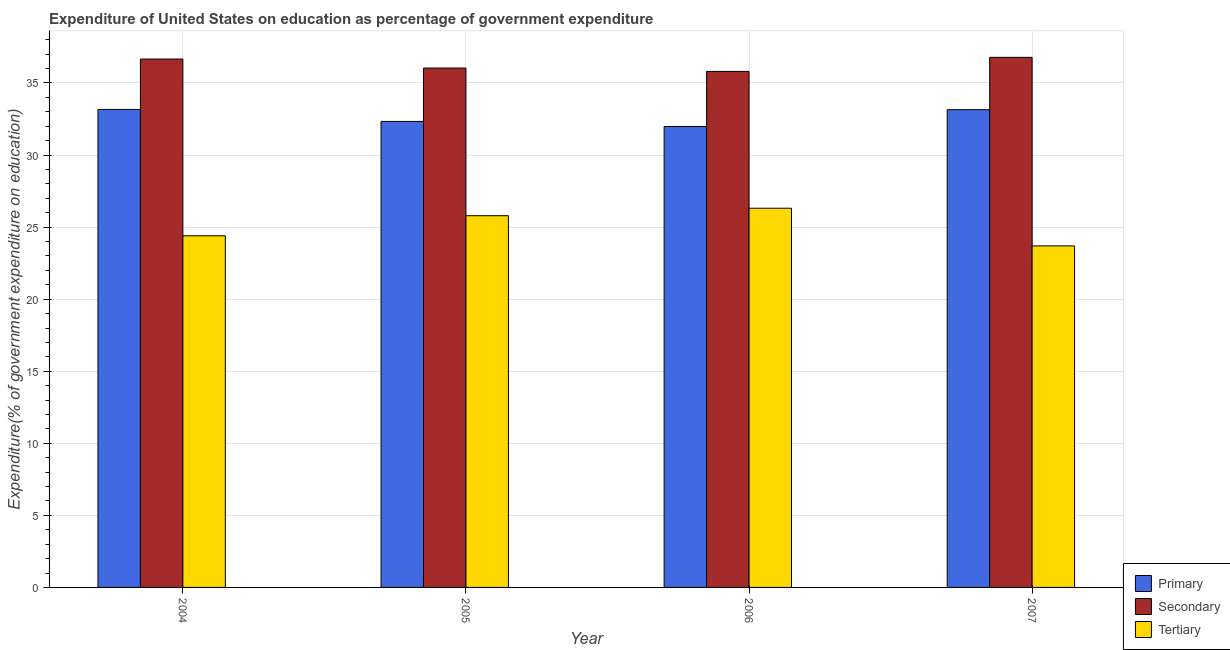Are the number of bars per tick equal to the number of legend labels?
Keep it short and to the point. Yes. In how many cases, is the number of bars for a given year not equal to the number of legend labels?
Keep it short and to the point. 0. What is the expenditure on tertiary education in 2006?
Provide a succinct answer. 26.31. Across all years, what is the maximum expenditure on primary education?
Your answer should be very brief. 33.16. Across all years, what is the minimum expenditure on primary education?
Provide a short and direct response. 31.98. What is the total expenditure on primary education in the graph?
Keep it short and to the point. 130.63. What is the difference between the expenditure on tertiary education in 2004 and that in 2006?
Give a very brief answer. -1.91. What is the difference between the expenditure on primary education in 2007 and the expenditure on secondary education in 2005?
Your answer should be compact. 0.81. What is the average expenditure on tertiary education per year?
Give a very brief answer. 25.05. In the year 2006, what is the difference between the expenditure on primary education and expenditure on secondary education?
Your answer should be compact. 0. What is the ratio of the expenditure on primary education in 2005 to that in 2006?
Offer a terse response. 1.01. Is the expenditure on secondary education in 2005 less than that in 2007?
Your answer should be very brief. Yes. What is the difference between the highest and the second highest expenditure on tertiary education?
Ensure brevity in your answer.  0.52. What is the difference between the highest and the lowest expenditure on secondary education?
Make the answer very short. 0.97. What does the 2nd bar from the left in 2005 represents?
Offer a terse response. Secondary. What does the 3rd bar from the right in 2007 represents?
Provide a succinct answer. Primary. Is it the case that in every year, the sum of the expenditure on primary education and expenditure on secondary education is greater than the expenditure on tertiary education?
Ensure brevity in your answer.  Yes. How many bars are there?
Provide a succinct answer. 12. Are all the bars in the graph horizontal?
Keep it short and to the point. No. How many years are there in the graph?
Keep it short and to the point. 4. Does the graph contain any zero values?
Your response must be concise. No. Does the graph contain grids?
Keep it short and to the point. Yes. How are the legend labels stacked?
Provide a short and direct response. Vertical. What is the title of the graph?
Make the answer very short. Expenditure of United States on education as percentage of government expenditure. Does "Neonatal" appear as one of the legend labels in the graph?
Give a very brief answer. No. What is the label or title of the X-axis?
Make the answer very short. Year. What is the label or title of the Y-axis?
Provide a short and direct response. Expenditure(% of government expenditure on education). What is the Expenditure(% of government expenditure on education) of Primary in 2004?
Your response must be concise. 33.16. What is the Expenditure(% of government expenditure on education) in Secondary in 2004?
Your answer should be very brief. 36.66. What is the Expenditure(% of government expenditure on education) of Tertiary in 2004?
Your answer should be very brief. 24.4. What is the Expenditure(% of government expenditure on education) of Primary in 2005?
Your answer should be compact. 32.33. What is the Expenditure(% of government expenditure on education) in Secondary in 2005?
Offer a very short reply. 36.04. What is the Expenditure(% of government expenditure on education) in Tertiary in 2005?
Give a very brief answer. 25.79. What is the Expenditure(% of government expenditure on education) of Primary in 2006?
Offer a very short reply. 31.98. What is the Expenditure(% of government expenditure on education) in Secondary in 2006?
Provide a succinct answer. 35.81. What is the Expenditure(% of government expenditure on education) in Tertiary in 2006?
Your answer should be very brief. 26.31. What is the Expenditure(% of government expenditure on education) of Primary in 2007?
Offer a very short reply. 33.15. What is the Expenditure(% of government expenditure on education) of Secondary in 2007?
Provide a succinct answer. 36.78. What is the Expenditure(% of government expenditure on education) of Tertiary in 2007?
Your response must be concise. 23.7. Across all years, what is the maximum Expenditure(% of government expenditure on education) in Primary?
Keep it short and to the point. 33.16. Across all years, what is the maximum Expenditure(% of government expenditure on education) of Secondary?
Your answer should be very brief. 36.78. Across all years, what is the maximum Expenditure(% of government expenditure on education) in Tertiary?
Your response must be concise. 26.31. Across all years, what is the minimum Expenditure(% of government expenditure on education) of Primary?
Provide a short and direct response. 31.98. Across all years, what is the minimum Expenditure(% of government expenditure on education) in Secondary?
Keep it short and to the point. 35.81. Across all years, what is the minimum Expenditure(% of government expenditure on education) of Tertiary?
Your response must be concise. 23.7. What is the total Expenditure(% of government expenditure on education) of Primary in the graph?
Offer a very short reply. 130.63. What is the total Expenditure(% of government expenditure on education) of Secondary in the graph?
Offer a terse response. 145.29. What is the total Expenditure(% of government expenditure on education) in Tertiary in the graph?
Provide a short and direct response. 100.2. What is the difference between the Expenditure(% of government expenditure on education) of Primary in 2004 and that in 2005?
Provide a short and direct response. 0.83. What is the difference between the Expenditure(% of government expenditure on education) of Secondary in 2004 and that in 2005?
Provide a short and direct response. 0.62. What is the difference between the Expenditure(% of government expenditure on education) of Tertiary in 2004 and that in 2005?
Offer a terse response. -1.39. What is the difference between the Expenditure(% of government expenditure on education) in Primary in 2004 and that in 2006?
Your response must be concise. 1.18. What is the difference between the Expenditure(% of government expenditure on education) of Secondary in 2004 and that in 2006?
Make the answer very short. 0.86. What is the difference between the Expenditure(% of government expenditure on education) of Tertiary in 2004 and that in 2006?
Provide a short and direct response. -1.91. What is the difference between the Expenditure(% of government expenditure on education) of Primary in 2004 and that in 2007?
Make the answer very short. 0.02. What is the difference between the Expenditure(% of government expenditure on education) in Secondary in 2004 and that in 2007?
Provide a short and direct response. -0.12. What is the difference between the Expenditure(% of government expenditure on education) of Tertiary in 2004 and that in 2007?
Provide a short and direct response. 0.7. What is the difference between the Expenditure(% of government expenditure on education) of Primary in 2005 and that in 2006?
Your response must be concise. 0.35. What is the difference between the Expenditure(% of government expenditure on education) of Secondary in 2005 and that in 2006?
Provide a succinct answer. 0.23. What is the difference between the Expenditure(% of government expenditure on education) in Tertiary in 2005 and that in 2006?
Give a very brief answer. -0.52. What is the difference between the Expenditure(% of government expenditure on education) in Primary in 2005 and that in 2007?
Your answer should be very brief. -0.81. What is the difference between the Expenditure(% of government expenditure on education) in Secondary in 2005 and that in 2007?
Provide a short and direct response. -0.74. What is the difference between the Expenditure(% of government expenditure on education) in Tertiary in 2005 and that in 2007?
Provide a succinct answer. 2.09. What is the difference between the Expenditure(% of government expenditure on education) of Primary in 2006 and that in 2007?
Your response must be concise. -1.16. What is the difference between the Expenditure(% of government expenditure on education) in Secondary in 2006 and that in 2007?
Offer a terse response. -0.97. What is the difference between the Expenditure(% of government expenditure on education) in Tertiary in 2006 and that in 2007?
Offer a very short reply. 2.61. What is the difference between the Expenditure(% of government expenditure on education) of Primary in 2004 and the Expenditure(% of government expenditure on education) of Secondary in 2005?
Offer a terse response. -2.87. What is the difference between the Expenditure(% of government expenditure on education) in Primary in 2004 and the Expenditure(% of government expenditure on education) in Tertiary in 2005?
Give a very brief answer. 7.37. What is the difference between the Expenditure(% of government expenditure on education) of Secondary in 2004 and the Expenditure(% of government expenditure on education) of Tertiary in 2005?
Keep it short and to the point. 10.87. What is the difference between the Expenditure(% of government expenditure on education) in Primary in 2004 and the Expenditure(% of government expenditure on education) in Secondary in 2006?
Provide a short and direct response. -2.64. What is the difference between the Expenditure(% of government expenditure on education) of Primary in 2004 and the Expenditure(% of government expenditure on education) of Tertiary in 2006?
Your answer should be compact. 6.85. What is the difference between the Expenditure(% of government expenditure on education) in Secondary in 2004 and the Expenditure(% of government expenditure on education) in Tertiary in 2006?
Offer a very short reply. 10.35. What is the difference between the Expenditure(% of government expenditure on education) of Primary in 2004 and the Expenditure(% of government expenditure on education) of Secondary in 2007?
Your answer should be compact. -3.62. What is the difference between the Expenditure(% of government expenditure on education) of Primary in 2004 and the Expenditure(% of government expenditure on education) of Tertiary in 2007?
Make the answer very short. 9.47. What is the difference between the Expenditure(% of government expenditure on education) in Secondary in 2004 and the Expenditure(% of government expenditure on education) in Tertiary in 2007?
Your response must be concise. 12.96. What is the difference between the Expenditure(% of government expenditure on education) in Primary in 2005 and the Expenditure(% of government expenditure on education) in Secondary in 2006?
Make the answer very short. -3.47. What is the difference between the Expenditure(% of government expenditure on education) in Primary in 2005 and the Expenditure(% of government expenditure on education) in Tertiary in 2006?
Provide a succinct answer. 6.02. What is the difference between the Expenditure(% of government expenditure on education) of Secondary in 2005 and the Expenditure(% of government expenditure on education) of Tertiary in 2006?
Give a very brief answer. 9.73. What is the difference between the Expenditure(% of government expenditure on education) of Primary in 2005 and the Expenditure(% of government expenditure on education) of Secondary in 2007?
Offer a very short reply. -4.45. What is the difference between the Expenditure(% of government expenditure on education) in Primary in 2005 and the Expenditure(% of government expenditure on education) in Tertiary in 2007?
Make the answer very short. 8.64. What is the difference between the Expenditure(% of government expenditure on education) in Secondary in 2005 and the Expenditure(% of government expenditure on education) in Tertiary in 2007?
Ensure brevity in your answer.  12.34. What is the difference between the Expenditure(% of government expenditure on education) in Primary in 2006 and the Expenditure(% of government expenditure on education) in Secondary in 2007?
Your answer should be very brief. -4.8. What is the difference between the Expenditure(% of government expenditure on education) in Primary in 2006 and the Expenditure(% of government expenditure on education) in Tertiary in 2007?
Your answer should be compact. 8.29. What is the difference between the Expenditure(% of government expenditure on education) in Secondary in 2006 and the Expenditure(% of government expenditure on education) in Tertiary in 2007?
Provide a short and direct response. 12.11. What is the average Expenditure(% of government expenditure on education) of Primary per year?
Keep it short and to the point. 32.66. What is the average Expenditure(% of government expenditure on education) of Secondary per year?
Give a very brief answer. 36.32. What is the average Expenditure(% of government expenditure on education) of Tertiary per year?
Keep it short and to the point. 25.05. In the year 2004, what is the difference between the Expenditure(% of government expenditure on education) of Primary and Expenditure(% of government expenditure on education) of Secondary?
Provide a succinct answer. -3.5. In the year 2004, what is the difference between the Expenditure(% of government expenditure on education) in Primary and Expenditure(% of government expenditure on education) in Tertiary?
Make the answer very short. 8.77. In the year 2004, what is the difference between the Expenditure(% of government expenditure on education) in Secondary and Expenditure(% of government expenditure on education) in Tertiary?
Your response must be concise. 12.26. In the year 2005, what is the difference between the Expenditure(% of government expenditure on education) of Primary and Expenditure(% of government expenditure on education) of Secondary?
Offer a very short reply. -3.7. In the year 2005, what is the difference between the Expenditure(% of government expenditure on education) in Primary and Expenditure(% of government expenditure on education) in Tertiary?
Give a very brief answer. 6.54. In the year 2005, what is the difference between the Expenditure(% of government expenditure on education) of Secondary and Expenditure(% of government expenditure on education) of Tertiary?
Provide a succinct answer. 10.25. In the year 2006, what is the difference between the Expenditure(% of government expenditure on education) in Primary and Expenditure(% of government expenditure on education) in Secondary?
Your response must be concise. -3.82. In the year 2006, what is the difference between the Expenditure(% of government expenditure on education) in Primary and Expenditure(% of government expenditure on education) in Tertiary?
Keep it short and to the point. 5.67. In the year 2006, what is the difference between the Expenditure(% of government expenditure on education) of Secondary and Expenditure(% of government expenditure on education) of Tertiary?
Ensure brevity in your answer.  9.5. In the year 2007, what is the difference between the Expenditure(% of government expenditure on education) of Primary and Expenditure(% of government expenditure on education) of Secondary?
Ensure brevity in your answer.  -3.63. In the year 2007, what is the difference between the Expenditure(% of government expenditure on education) of Primary and Expenditure(% of government expenditure on education) of Tertiary?
Provide a succinct answer. 9.45. In the year 2007, what is the difference between the Expenditure(% of government expenditure on education) in Secondary and Expenditure(% of government expenditure on education) in Tertiary?
Offer a terse response. 13.08. What is the ratio of the Expenditure(% of government expenditure on education) in Primary in 2004 to that in 2005?
Give a very brief answer. 1.03. What is the ratio of the Expenditure(% of government expenditure on education) in Secondary in 2004 to that in 2005?
Keep it short and to the point. 1.02. What is the ratio of the Expenditure(% of government expenditure on education) of Tertiary in 2004 to that in 2005?
Offer a terse response. 0.95. What is the ratio of the Expenditure(% of government expenditure on education) of Primary in 2004 to that in 2006?
Offer a terse response. 1.04. What is the ratio of the Expenditure(% of government expenditure on education) of Secondary in 2004 to that in 2006?
Give a very brief answer. 1.02. What is the ratio of the Expenditure(% of government expenditure on education) of Tertiary in 2004 to that in 2006?
Keep it short and to the point. 0.93. What is the ratio of the Expenditure(% of government expenditure on education) of Primary in 2004 to that in 2007?
Ensure brevity in your answer.  1. What is the ratio of the Expenditure(% of government expenditure on education) in Tertiary in 2004 to that in 2007?
Your answer should be compact. 1.03. What is the ratio of the Expenditure(% of government expenditure on education) of Primary in 2005 to that in 2006?
Your response must be concise. 1.01. What is the ratio of the Expenditure(% of government expenditure on education) in Secondary in 2005 to that in 2006?
Give a very brief answer. 1.01. What is the ratio of the Expenditure(% of government expenditure on education) in Tertiary in 2005 to that in 2006?
Give a very brief answer. 0.98. What is the ratio of the Expenditure(% of government expenditure on education) in Primary in 2005 to that in 2007?
Give a very brief answer. 0.98. What is the ratio of the Expenditure(% of government expenditure on education) in Secondary in 2005 to that in 2007?
Ensure brevity in your answer.  0.98. What is the ratio of the Expenditure(% of government expenditure on education) in Tertiary in 2005 to that in 2007?
Your response must be concise. 1.09. What is the ratio of the Expenditure(% of government expenditure on education) of Primary in 2006 to that in 2007?
Keep it short and to the point. 0.96. What is the ratio of the Expenditure(% of government expenditure on education) in Secondary in 2006 to that in 2007?
Make the answer very short. 0.97. What is the ratio of the Expenditure(% of government expenditure on education) of Tertiary in 2006 to that in 2007?
Your answer should be very brief. 1.11. What is the difference between the highest and the second highest Expenditure(% of government expenditure on education) of Primary?
Offer a very short reply. 0.02. What is the difference between the highest and the second highest Expenditure(% of government expenditure on education) in Secondary?
Keep it short and to the point. 0.12. What is the difference between the highest and the second highest Expenditure(% of government expenditure on education) of Tertiary?
Make the answer very short. 0.52. What is the difference between the highest and the lowest Expenditure(% of government expenditure on education) in Primary?
Offer a terse response. 1.18. What is the difference between the highest and the lowest Expenditure(% of government expenditure on education) of Secondary?
Make the answer very short. 0.97. What is the difference between the highest and the lowest Expenditure(% of government expenditure on education) in Tertiary?
Make the answer very short. 2.61. 